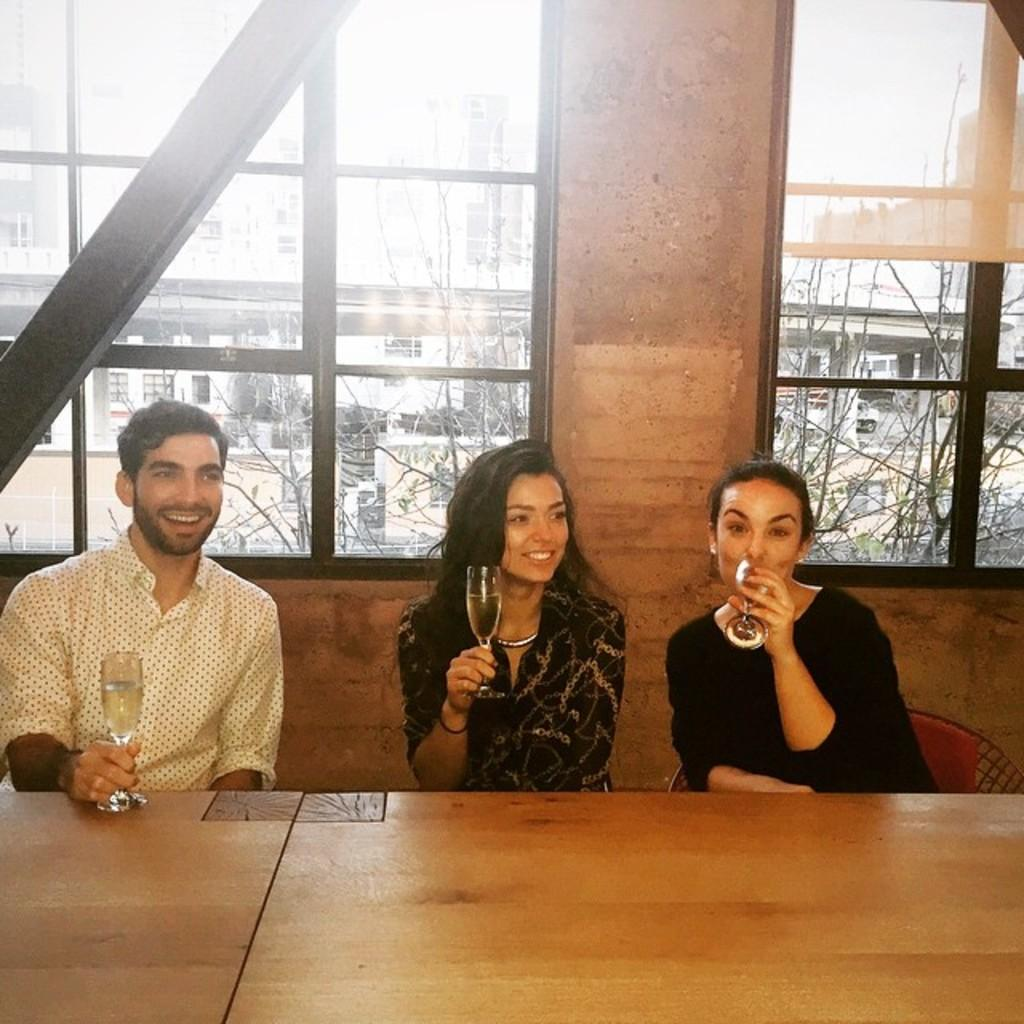How many people are in the image? There are three persons in the image. What are the persons doing in the image? The persons are sitting on chairs and holding glasses. What can be seen on the tables in the image? The tables are not described in the facts, so we cannot determine what is on them. What is visible in the background of the image? In the background, there are windows, buildings, trees, and the sky. What type of alley can be seen behind the persons in the image? There is no alley present in the image; the background features windows, buildings, trees, and the sky. What is the friction between the persons and the chairs in the image? The facts do not provide information about friction, so we cannot determine the friction between the persons and the chairs. 